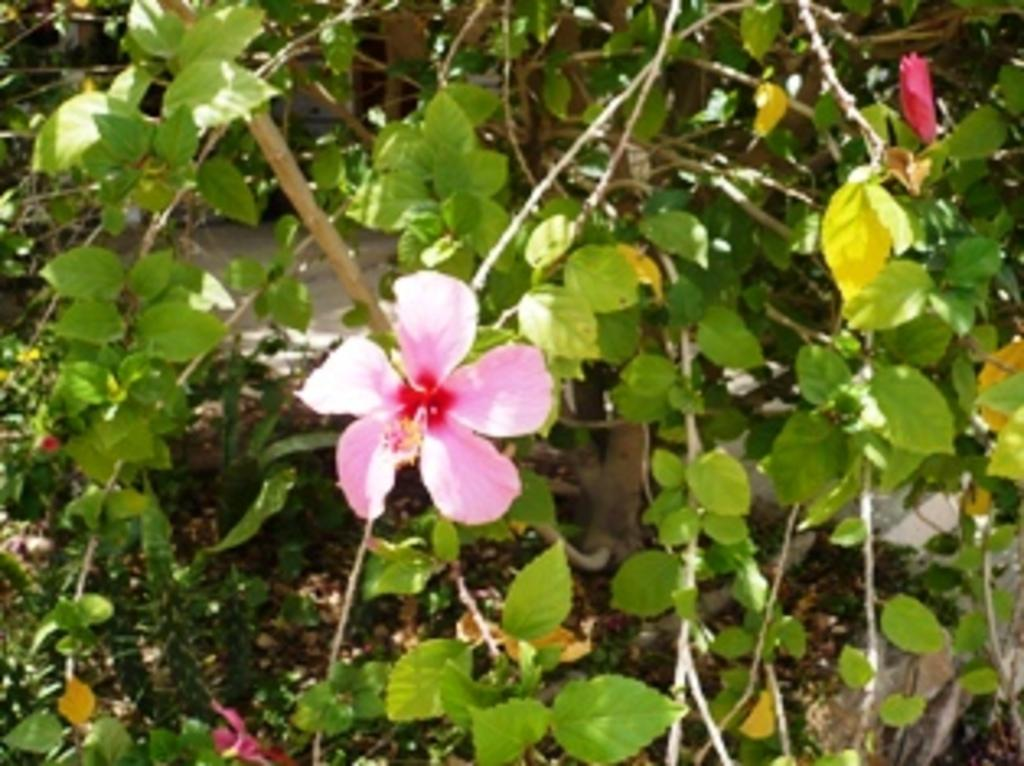What type of living organisms can be seen in the image? There are flowers and plants in the image. Can you describe the plants in the image? The plants in the image are not specified, but they are present alongside the flowers. How many cars can be seen in the image? There are no cars present in the image; it features flowers and plants. What is the range of the grip in the image? There is no grip present in the image, as it features flowers and plants. 